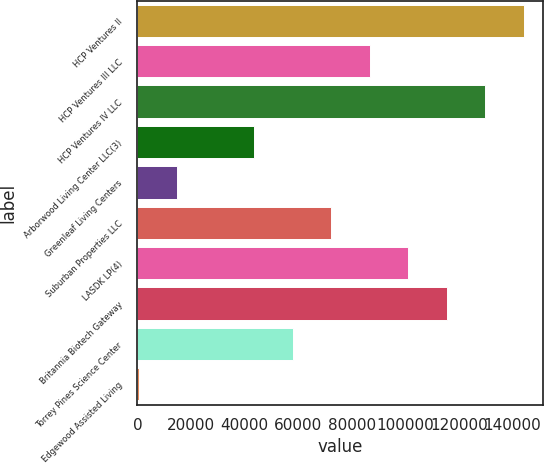<chart> <loc_0><loc_0><loc_500><loc_500><bar_chart><fcel>HCP Ventures II<fcel>HCP Ventures III LLC<fcel>HCP Ventures IV LLC<fcel>Arborwood Living Center LLC(3)<fcel>Greenleaf Living Centers<fcel>Suburban Properties LLC<fcel>LASDK LP(4)<fcel>Britannia Biotech Gateway<fcel>Torrey Pines Science Center<fcel>Edgewood Assisted Living<nl><fcel>144228<fcel>86700.8<fcel>129846<fcel>43555.4<fcel>14791.8<fcel>72319<fcel>101083<fcel>115464<fcel>57937.2<fcel>410<nl></chart> 